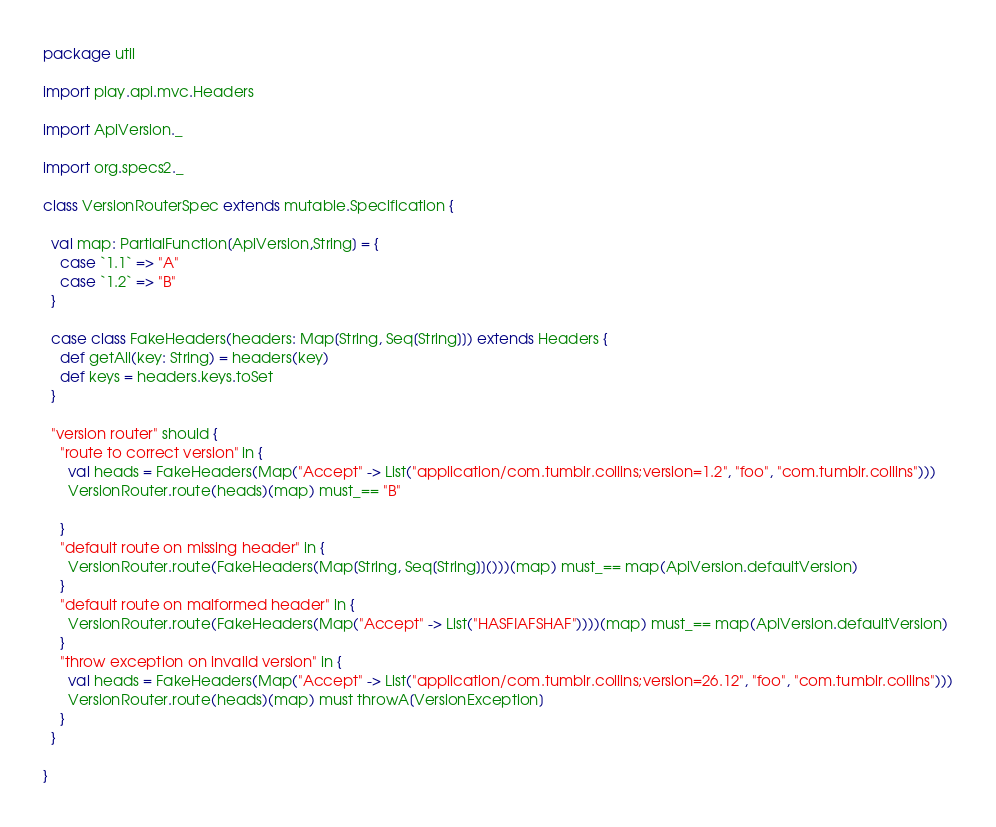Convert code to text. <code><loc_0><loc_0><loc_500><loc_500><_Scala_>package util

import play.api.mvc.Headers

import ApiVersion._

import org.specs2._

class VersionRouterSpec extends mutable.Specification {

  val map: PartialFunction[ApiVersion,String] = {
    case `1.1` => "A"
    case `1.2` => "B"
  }

  case class FakeHeaders(headers: Map[String, Seq[String]]) extends Headers {
    def getAll(key: String) = headers(key)
    def keys = headers.keys.toSet
  }

  "version router" should {
    "route to correct version" in {
      val heads = FakeHeaders(Map("Accept" -> List("application/com.tumblr.collins;version=1.2", "foo", "com.tumblr.collins")))
      VersionRouter.route(heads)(map) must_== "B"

    }
    "default route on missing header" in {      
      VersionRouter.route(FakeHeaders(Map[String, Seq[String]]()))(map) must_== map(ApiVersion.defaultVersion)
    }
    "default route on malformed header" in {
      VersionRouter.route(FakeHeaders(Map("Accept" -> List("HASFIAFSHAF"))))(map) must_== map(ApiVersion.defaultVersion)
    }
    "throw exception on invalid version" in {
      val heads = FakeHeaders(Map("Accept" -> List("application/com.tumblr.collins;version=26.12", "foo", "com.tumblr.collins")))
      VersionRouter.route(heads)(map) must throwA[VersionException]
    }
  }

}
</code> 